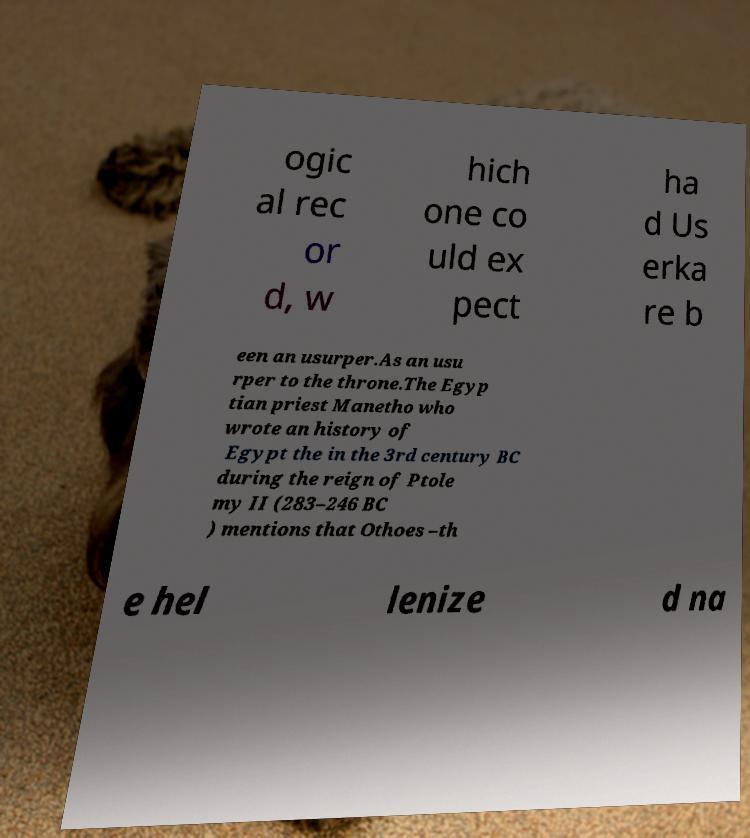There's text embedded in this image that I need extracted. Can you transcribe it verbatim? ogic al rec or d, w hich one co uld ex pect ha d Us erka re b een an usurper.As an usu rper to the throne.The Egyp tian priest Manetho who wrote an history of Egypt the in the 3rd century BC during the reign of Ptole my II (283–246 BC ) mentions that Othoes –th e hel lenize d na 